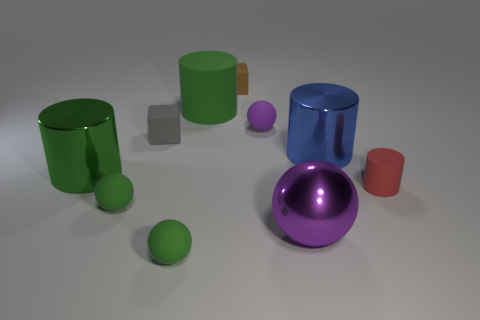There is a ball behind the tiny red matte cylinder; does it have the same color as the metallic ball?
Ensure brevity in your answer.  Yes. There is a purple thing behind the green metallic object; what size is it?
Your response must be concise. Small. Is the color of the rubber cylinder on the left side of the red rubber object the same as the big object to the left of the large green rubber thing?
Keep it short and to the point. Yes. What number of other objects are there of the same shape as the red matte object?
Provide a succinct answer. 3. Are there the same number of small matte balls that are left of the brown block and blue metallic cylinders left of the purple metal thing?
Your answer should be very brief. No. Is the sphere that is behind the small red rubber thing made of the same material as the large green object that is in front of the purple rubber sphere?
Provide a short and direct response. No. What number of other objects are the same size as the purple metal ball?
Your response must be concise. 3. What number of things are either purple shiny balls or small green spheres that are behind the big ball?
Provide a succinct answer. 2. Are there the same number of small purple objects on the right side of the tiny rubber cylinder and large yellow shiny balls?
Your response must be concise. Yes. The small gray object that is the same material as the small brown thing is what shape?
Offer a very short reply. Cube. 